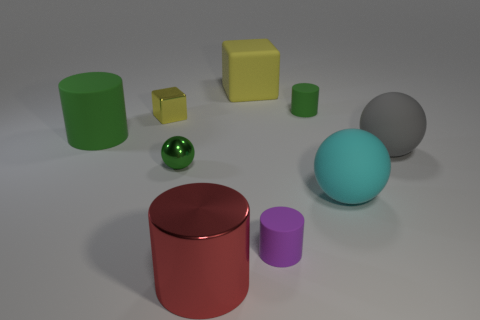Subtract all big cyan spheres. How many spheres are left? 2 Add 1 tiny yellow metallic blocks. How many objects exist? 10 Subtract all purple cylinders. How many cylinders are left? 3 Subtract all spheres. How many objects are left? 6 Subtract 1 cylinders. How many cylinders are left? 3 Subtract all large matte things. Subtract all small metal objects. How many objects are left? 3 Add 6 tiny balls. How many tiny balls are left? 7 Add 5 large yellow objects. How many large yellow objects exist? 6 Subtract 0 gray cylinders. How many objects are left? 9 Subtract all red cubes. Subtract all yellow balls. How many cubes are left? 2 